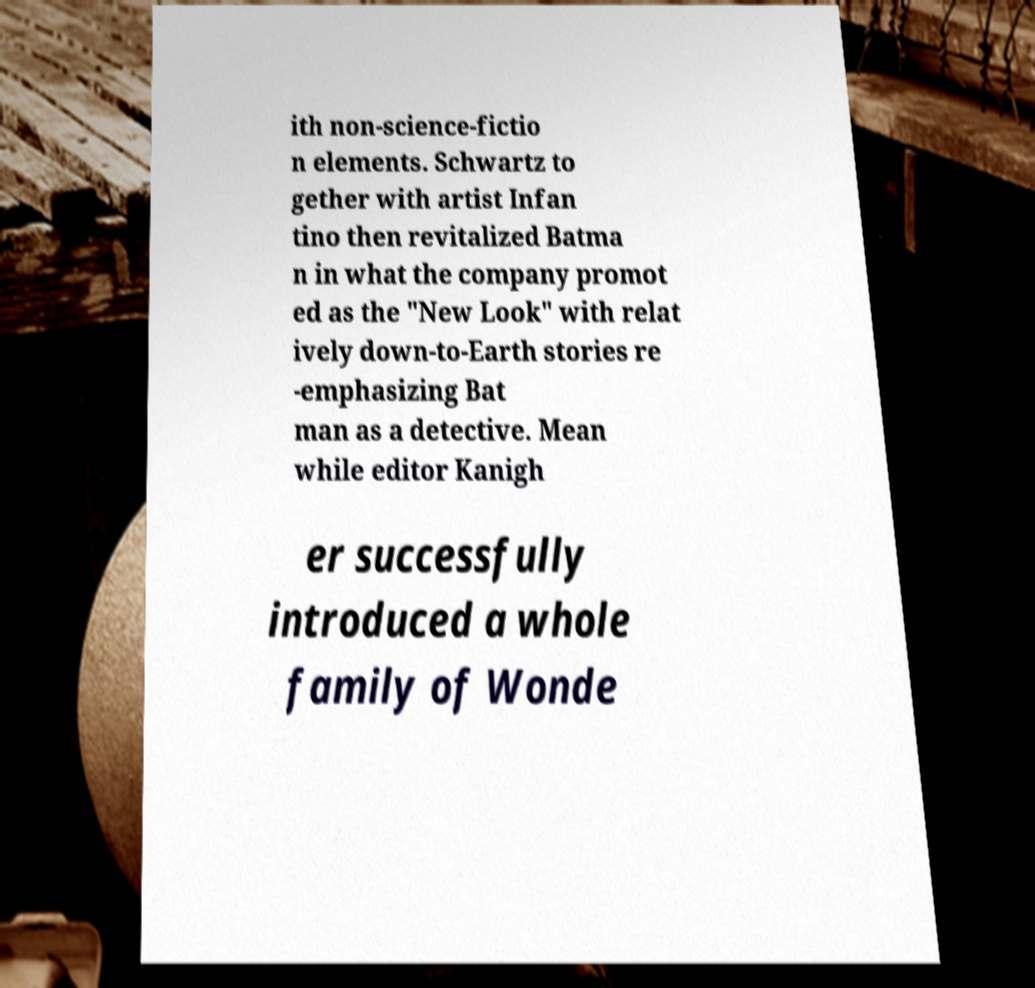Please read and relay the text visible in this image. What does it say? ith non-science-fictio n elements. Schwartz to gether with artist Infan tino then revitalized Batma n in what the company promot ed as the "New Look" with relat ively down-to-Earth stories re -emphasizing Bat man as a detective. Mean while editor Kanigh er successfully introduced a whole family of Wonde 